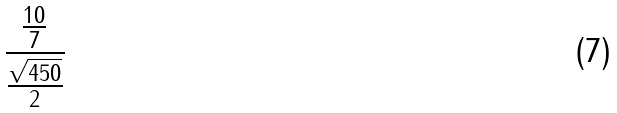Convert formula to latex. <formula><loc_0><loc_0><loc_500><loc_500>\frac { \frac { 1 0 } { 7 } } { \frac { \sqrt { 4 5 0 } } { 2 } }</formula> 